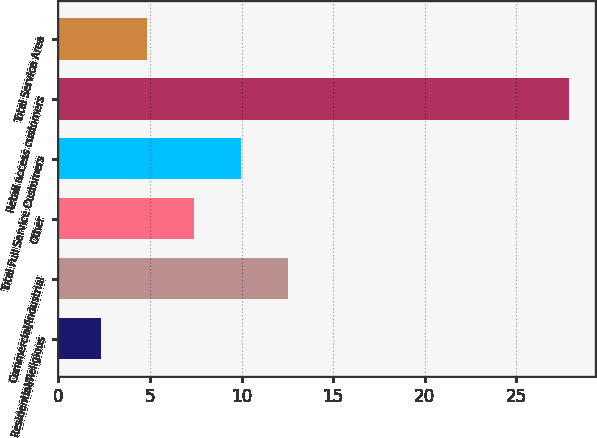Convert chart to OTSL. <chart><loc_0><loc_0><loc_500><loc_500><bar_chart><fcel>Residential/Religious<fcel>Commercial/Industrial<fcel>Other<fcel>Total Full Service Customers<fcel>Retail access customers<fcel>Total Service Area<nl><fcel>2.3<fcel>12.54<fcel>7.42<fcel>9.98<fcel>27.9<fcel>4.86<nl></chart> 